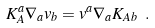<formula> <loc_0><loc_0><loc_500><loc_500>K _ { A } ^ { a } \nabla _ { a } v _ { b } = v ^ { a } \nabla _ { a } K _ { A b } \ .</formula> 